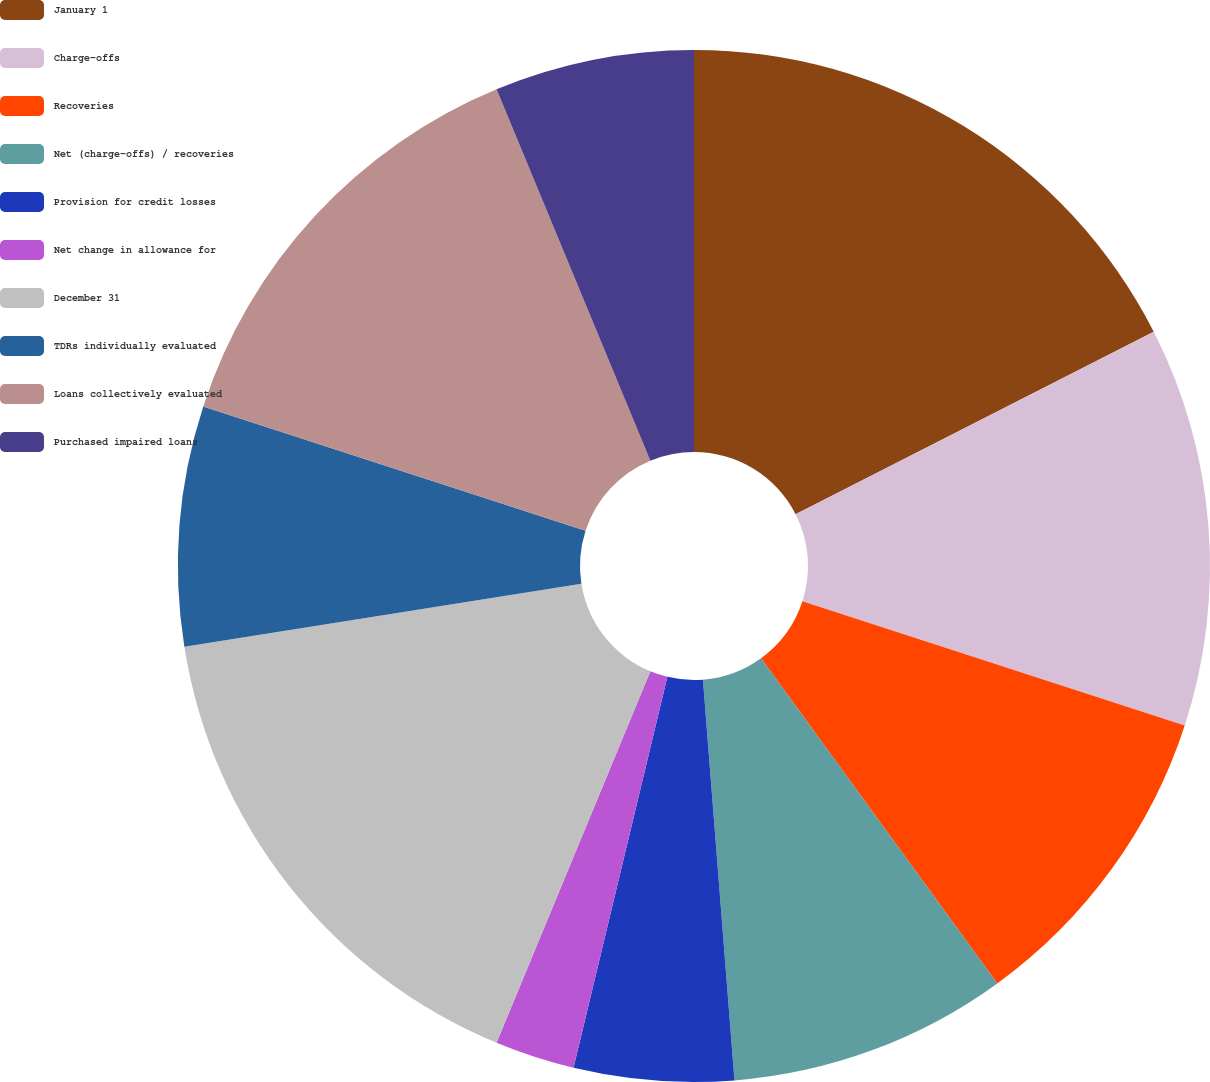<chart> <loc_0><loc_0><loc_500><loc_500><pie_chart><fcel>January 1<fcel>Charge-offs<fcel>Recoveries<fcel>Net (charge-offs) / recoveries<fcel>Provision for credit losses<fcel>Net change in allowance for<fcel>December 31<fcel>TDRs individually evaluated<fcel>Loans collectively evaluated<fcel>Purchased impaired loans<nl><fcel>17.5%<fcel>12.5%<fcel>10.0%<fcel>8.75%<fcel>5.0%<fcel>2.5%<fcel>16.25%<fcel>7.5%<fcel>13.75%<fcel>6.25%<nl></chart> 